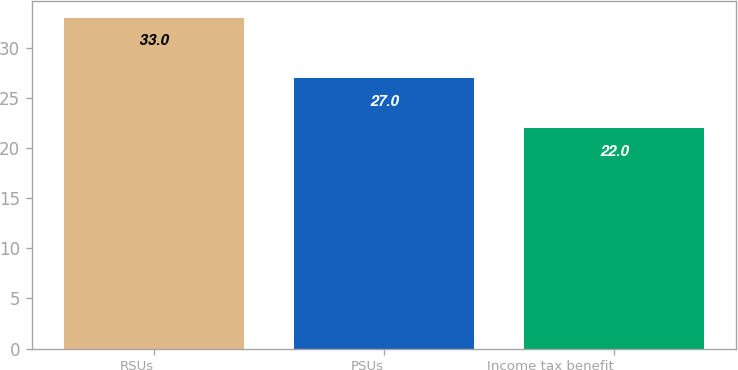<chart> <loc_0><loc_0><loc_500><loc_500><bar_chart><fcel>RSUs<fcel>PSUs<fcel>Income tax benefit<nl><fcel>33<fcel>27<fcel>22<nl></chart> 